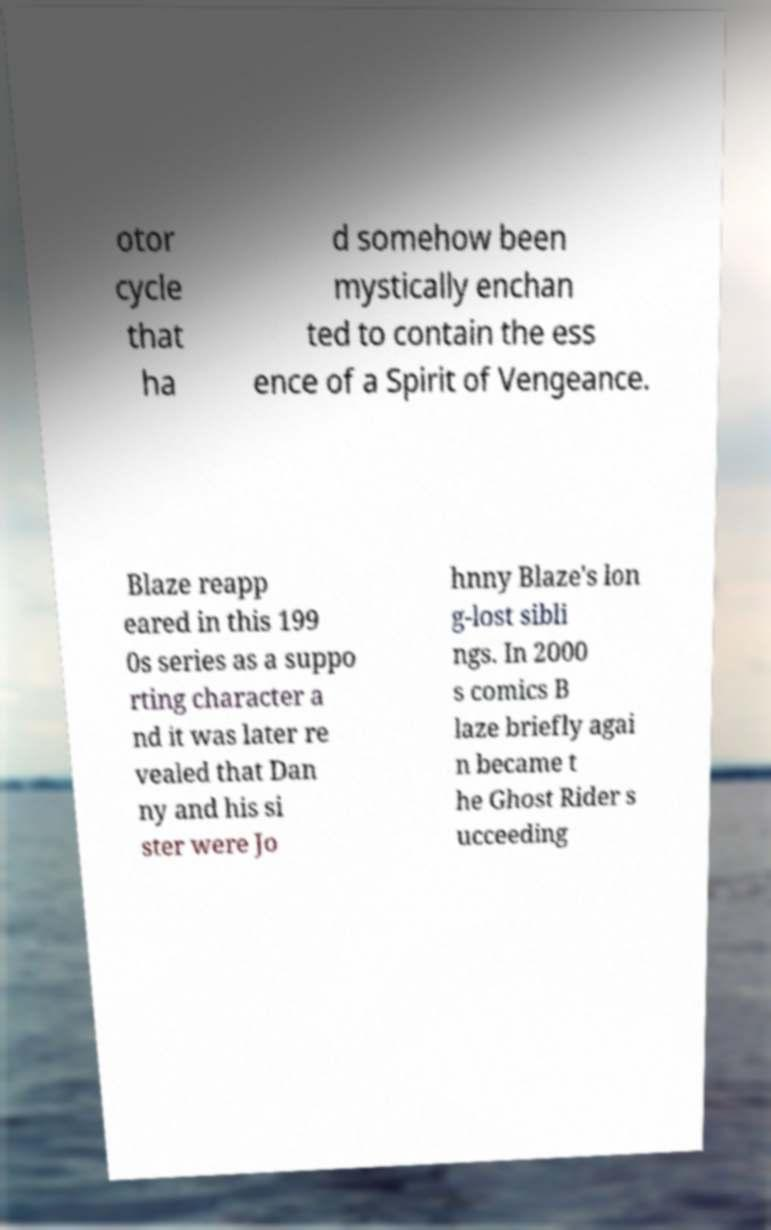Can you accurately transcribe the text from the provided image for me? otor cycle that ha d somehow been mystically enchan ted to contain the ess ence of a Spirit of Vengeance. Blaze reapp eared in this 199 0s series as a suppo rting character a nd it was later re vealed that Dan ny and his si ster were Jo hnny Blaze's lon g-lost sibli ngs. In 2000 s comics B laze briefly agai n became t he Ghost Rider s ucceeding 